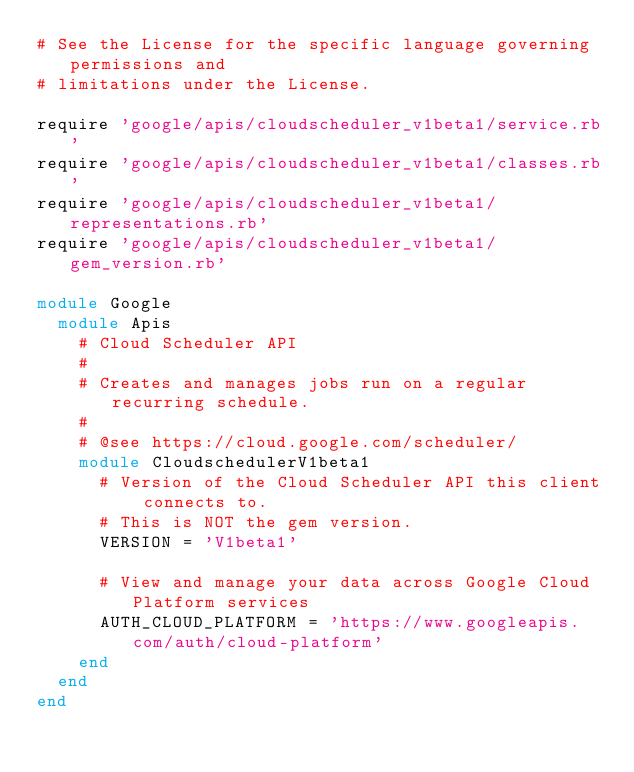<code> <loc_0><loc_0><loc_500><loc_500><_Ruby_># See the License for the specific language governing permissions and
# limitations under the License.

require 'google/apis/cloudscheduler_v1beta1/service.rb'
require 'google/apis/cloudscheduler_v1beta1/classes.rb'
require 'google/apis/cloudscheduler_v1beta1/representations.rb'
require 'google/apis/cloudscheduler_v1beta1/gem_version.rb'

module Google
  module Apis
    # Cloud Scheduler API
    #
    # Creates and manages jobs run on a regular recurring schedule.
    #
    # @see https://cloud.google.com/scheduler/
    module CloudschedulerV1beta1
      # Version of the Cloud Scheduler API this client connects to.
      # This is NOT the gem version.
      VERSION = 'V1beta1'

      # View and manage your data across Google Cloud Platform services
      AUTH_CLOUD_PLATFORM = 'https://www.googleapis.com/auth/cloud-platform'
    end
  end
end
</code> 